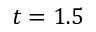<formula> <loc_0><loc_0><loc_500><loc_500>t = 1 . 5</formula> 